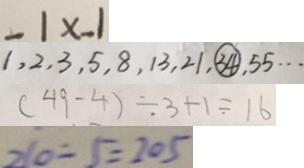Convert formula to latex. <formula><loc_0><loc_0><loc_500><loc_500>- 1 x - 1 
 1 , 2 , 3 , 5 , 8 , 1 3 , 2 1 , \textcircled { 3 4 } , 5 5 \cdots 
 ( 4 9 - 4 ) \div 3 + 1 = 1 6 
 2 1 0 - 5 = 2 0 5</formula> 